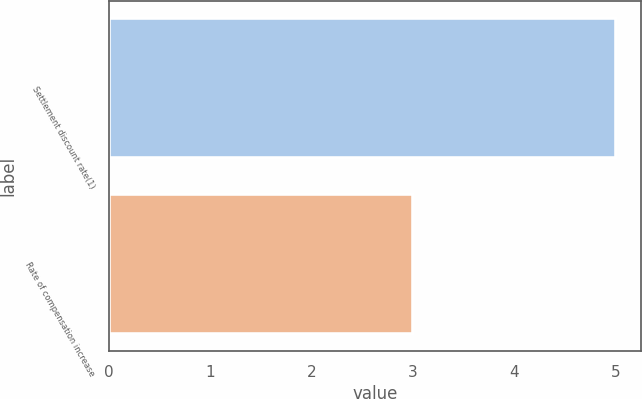Convert chart to OTSL. <chart><loc_0><loc_0><loc_500><loc_500><bar_chart><fcel>Settlement discount rate(1)<fcel>Rate of compensation increase<nl><fcel>5<fcel>3<nl></chart> 